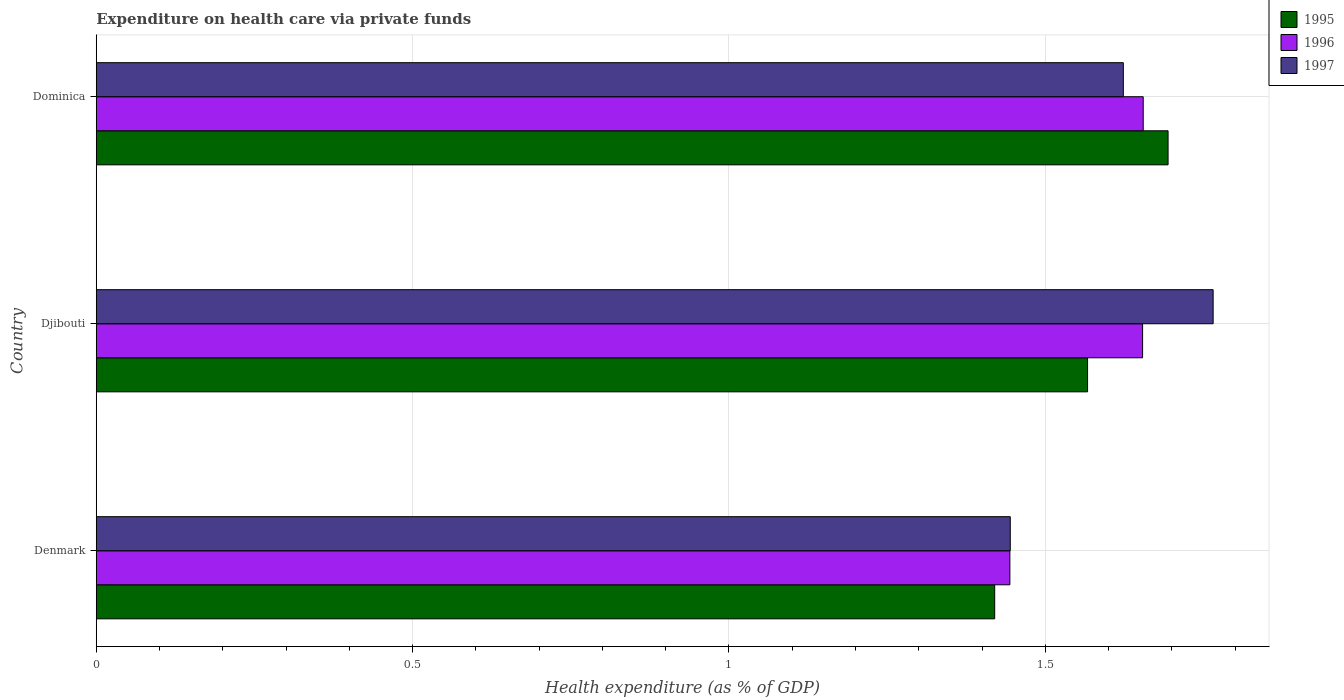How many different coloured bars are there?
Keep it short and to the point. 3. How many groups of bars are there?
Give a very brief answer. 3. Are the number of bars on each tick of the Y-axis equal?
Keep it short and to the point. Yes. How many bars are there on the 3rd tick from the top?
Keep it short and to the point. 3. What is the label of the 2nd group of bars from the top?
Keep it short and to the point. Djibouti. In how many cases, is the number of bars for a given country not equal to the number of legend labels?
Ensure brevity in your answer.  0. What is the expenditure made on health care in 1997 in Denmark?
Keep it short and to the point. 1.44. Across all countries, what is the maximum expenditure made on health care in 1996?
Provide a succinct answer. 1.65. Across all countries, what is the minimum expenditure made on health care in 1996?
Keep it short and to the point. 1.44. In which country was the expenditure made on health care in 1996 maximum?
Your answer should be very brief. Dominica. What is the total expenditure made on health care in 1996 in the graph?
Offer a terse response. 4.75. What is the difference between the expenditure made on health care in 1995 in Denmark and that in Djibouti?
Offer a very short reply. -0.15. What is the difference between the expenditure made on health care in 1996 in Denmark and the expenditure made on health care in 1997 in Djibouti?
Your response must be concise. -0.32. What is the average expenditure made on health care in 1995 per country?
Your answer should be compact. 1.56. What is the difference between the expenditure made on health care in 1995 and expenditure made on health care in 1996 in Djibouti?
Offer a terse response. -0.09. In how many countries, is the expenditure made on health care in 1995 greater than 0.9 %?
Ensure brevity in your answer.  3. What is the ratio of the expenditure made on health care in 1996 in Denmark to that in Dominica?
Your answer should be very brief. 0.87. What is the difference between the highest and the second highest expenditure made on health care in 1995?
Provide a succinct answer. 0.13. What is the difference between the highest and the lowest expenditure made on health care in 1997?
Make the answer very short. 0.32. What does the 3rd bar from the top in Dominica represents?
Provide a succinct answer. 1995. Is it the case that in every country, the sum of the expenditure made on health care in 1997 and expenditure made on health care in 1996 is greater than the expenditure made on health care in 1995?
Your response must be concise. Yes. Are all the bars in the graph horizontal?
Provide a short and direct response. Yes. How many countries are there in the graph?
Your answer should be compact. 3. What is the difference between two consecutive major ticks on the X-axis?
Provide a succinct answer. 0.5. Are the values on the major ticks of X-axis written in scientific E-notation?
Make the answer very short. No. How many legend labels are there?
Your response must be concise. 3. What is the title of the graph?
Provide a short and direct response. Expenditure on health care via private funds. Does "1965" appear as one of the legend labels in the graph?
Provide a short and direct response. No. What is the label or title of the X-axis?
Ensure brevity in your answer.  Health expenditure (as % of GDP). What is the label or title of the Y-axis?
Keep it short and to the point. Country. What is the Health expenditure (as % of GDP) of 1995 in Denmark?
Ensure brevity in your answer.  1.42. What is the Health expenditure (as % of GDP) in 1996 in Denmark?
Provide a short and direct response. 1.44. What is the Health expenditure (as % of GDP) in 1997 in Denmark?
Offer a terse response. 1.44. What is the Health expenditure (as % of GDP) in 1995 in Djibouti?
Offer a terse response. 1.57. What is the Health expenditure (as % of GDP) in 1996 in Djibouti?
Your answer should be compact. 1.65. What is the Health expenditure (as % of GDP) in 1997 in Djibouti?
Give a very brief answer. 1.77. What is the Health expenditure (as % of GDP) in 1995 in Dominica?
Offer a very short reply. 1.69. What is the Health expenditure (as % of GDP) of 1996 in Dominica?
Give a very brief answer. 1.65. What is the Health expenditure (as % of GDP) in 1997 in Dominica?
Ensure brevity in your answer.  1.62. Across all countries, what is the maximum Health expenditure (as % of GDP) in 1995?
Your response must be concise. 1.69. Across all countries, what is the maximum Health expenditure (as % of GDP) of 1996?
Provide a short and direct response. 1.65. Across all countries, what is the maximum Health expenditure (as % of GDP) of 1997?
Your answer should be very brief. 1.77. Across all countries, what is the minimum Health expenditure (as % of GDP) in 1995?
Your response must be concise. 1.42. Across all countries, what is the minimum Health expenditure (as % of GDP) of 1996?
Your response must be concise. 1.44. Across all countries, what is the minimum Health expenditure (as % of GDP) of 1997?
Offer a terse response. 1.44. What is the total Health expenditure (as % of GDP) in 1995 in the graph?
Provide a short and direct response. 4.68. What is the total Health expenditure (as % of GDP) of 1996 in the graph?
Provide a succinct answer. 4.75. What is the total Health expenditure (as % of GDP) of 1997 in the graph?
Your answer should be compact. 4.83. What is the difference between the Health expenditure (as % of GDP) of 1995 in Denmark and that in Djibouti?
Ensure brevity in your answer.  -0.15. What is the difference between the Health expenditure (as % of GDP) of 1996 in Denmark and that in Djibouti?
Offer a terse response. -0.21. What is the difference between the Health expenditure (as % of GDP) of 1997 in Denmark and that in Djibouti?
Your answer should be very brief. -0.32. What is the difference between the Health expenditure (as % of GDP) in 1995 in Denmark and that in Dominica?
Your response must be concise. -0.27. What is the difference between the Health expenditure (as % of GDP) of 1996 in Denmark and that in Dominica?
Provide a short and direct response. -0.21. What is the difference between the Health expenditure (as % of GDP) in 1997 in Denmark and that in Dominica?
Give a very brief answer. -0.18. What is the difference between the Health expenditure (as % of GDP) in 1995 in Djibouti and that in Dominica?
Your response must be concise. -0.13. What is the difference between the Health expenditure (as % of GDP) of 1996 in Djibouti and that in Dominica?
Give a very brief answer. -0. What is the difference between the Health expenditure (as % of GDP) in 1997 in Djibouti and that in Dominica?
Your answer should be very brief. 0.14. What is the difference between the Health expenditure (as % of GDP) in 1995 in Denmark and the Health expenditure (as % of GDP) in 1996 in Djibouti?
Your answer should be compact. -0.23. What is the difference between the Health expenditure (as % of GDP) in 1995 in Denmark and the Health expenditure (as % of GDP) in 1997 in Djibouti?
Give a very brief answer. -0.35. What is the difference between the Health expenditure (as % of GDP) of 1996 in Denmark and the Health expenditure (as % of GDP) of 1997 in Djibouti?
Ensure brevity in your answer.  -0.32. What is the difference between the Health expenditure (as % of GDP) of 1995 in Denmark and the Health expenditure (as % of GDP) of 1996 in Dominica?
Ensure brevity in your answer.  -0.23. What is the difference between the Health expenditure (as % of GDP) of 1995 in Denmark and the Health expenditure (as % of GDP) of 1997 in Dominica?
Give a very brief answer. -0.2. What is the difference between the Health expenditure (as % of GDP) of 1996 in Denmark and the Health expenditure (as % of GDP) of 1997 in Dominica?
Offer a terse response. -0.18. What is the difference between the Health expenditure (as % of GDP) in 1995 in Djibouti and the Health expenditure (as % of GDP) in 1996 in Dominica?
Give a very brief answer. -0.09. What is the difference between the Health expenditure (as % of GDP) of 1995 in Djibouti and the Health expenditure (as % of GDP) of 1997 in Dominica?
Provide a succinct answer. -0.06. What is the difference between the Health expenditure (as % of GDP) in 1996 in Djibouti and the Health expenditure (as % of GDP) in 1997 in Dominica?
Provide a short and direct response. 0.03. What is the average Health expenditure (as % of GDP) in 1995 per country?
Offer a very short reply. 1.56. What is the average Health expenditure (as % of GDP) of 1996 per country?
Provide a succinct answer. 1.58. What is the average Health expenditure (as % of GDP) in 1997 per country?
Offer a very short reply. 1.61. What is the difference between the Health expenditure (as % of GDP) of 1995 and Health expenditure (as % of GDP) of 1996 in Denmark?
Keep it short and to the point. -0.02. What is the difference between the Health expenditure (as % of GDP) in 1995 and Health expenditure (as % of GDP) in 1997 in Denmark?
Provide a short and direct response. -0.02. What is the difference between the Health expenditure (as % of GDP) of 1996 and Health expenditure (as % of GDP) of 1997 in Denmark?
Keep it short and to the point. -0. What is the difference between the Health expenditure (as % of GDP) of 1995 and Health expenditure (as % of GDP) of 1996 in Djibouti?
Ensure brevity in your answer.  -0.09. What is the difference between the Health expenditure (as % of GDP) in 1995 and Health expenditure (as % of GDP) in 1997 in Djibouti?
Provide a short and direct response. -0.2. What is the difference between the Health expenditure (as % of GDP) of 1996 and Health expenditure (as % of GDP) of 1997 in Djibouti?
Provide a short and direct response. -0.11. What is the difference between the Health expenditure (as % of GDP) in 1995 and Health expenditure (as % of GDP) in 1996 in Dominica?
Your answer should be very brief. 0.04. What is the difference between the Health expenditure (as % of GDP) in 1995 and Health expenditure (as % of GDP) in 1997 in Dominica?
Provide a succinct answer. 0.07. What is the difference between the Health expenditure (as % of GDP) of 1996 and Health expenditure (as % of GDP) of 1997 in Dominica?
Your response must be concise. 0.03. What is the ratio of the Health expenditure (as % of GDP) in 1995 in Denmark to that in Djibouti?
Ensure brevity in your answer.  0.91. What is the ratio of the Health expenditure (as % of GDP) of 1996 in Denmark to that in Djibouti?
Keep it short and to the point. 0.87. What is the ratio of the Health expenditure (as % of GDP) in 1997 in Denmark to that in Djibouti?
Your answer should be compact. 0.82. What is the ratio of the Health expenditure (as % of GDP) in 1995 in Denmark to that in Dominica?
Your response must be concise. 0.84. What is the ratio of the Health expenditure (as % of GDP) in 1996 in Denmark to that in Dominica?
Your answer should be very brief. 0.87. What is the ratio of the Health expenditure (as % of GDP) of 1997 in Denmark to that in Dominica?
Provide a short and direct response. 0.89. What is the ratio of the Health expenditure (as % of GDP) in 1995 in Djibouti to that in Dominica?
Ensure brevity in your answer.  0.92. What is the ratio of the Health expenditure (as % of GDP) of 1996 in Djibouti to that in Dominica?
Provide a short and direct response. 1. What is the ratio of the Health expenditure (as % of GDP) in 1997 in Djibouti to that in Dominica?
Your answer should be very brief. 1.09. What is the difference between the highest and the second highest Health expenditure (as % of GDP) of 1995?
Your answer should be compact. 0.13. What is the difference between the highest and the second highest Health expenditure (as % of GDP) in 1996?
Give a very brief answer. 0. What is the difference between the highest and the second highest Health expenditure (as % of GDP) of 1997?
Keep it short and to the point. 0.14. What is the difference between the highest and the lowest Health expenditure (as % of GDP) of 1995?
Your answer should be very brief. 0.27. What is the difference between the highest and the lowest Health expenditure (as % of GDP) of 1996?
Give a very brief answer. 0.21. What is the difference between the highest and the lowest Health expenditure (as % of GDP) in 1997?
Ensure brevity in your answer.  0.32. 